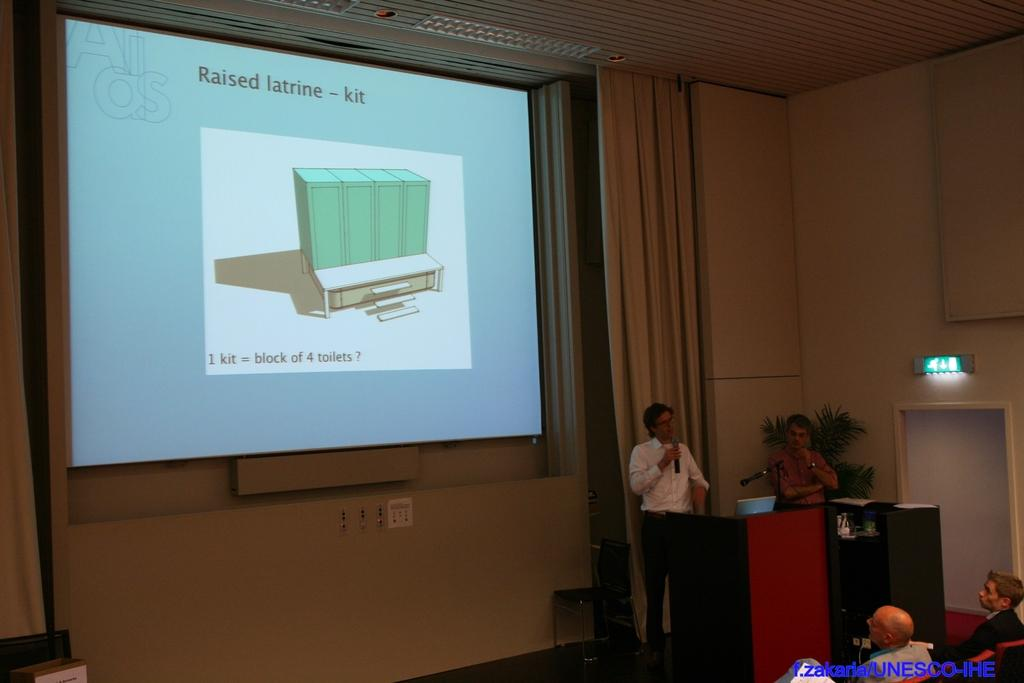Provide a one-sentence caption for the provided image. A lecturer orates in front of a screen with raised latrine information on it. 